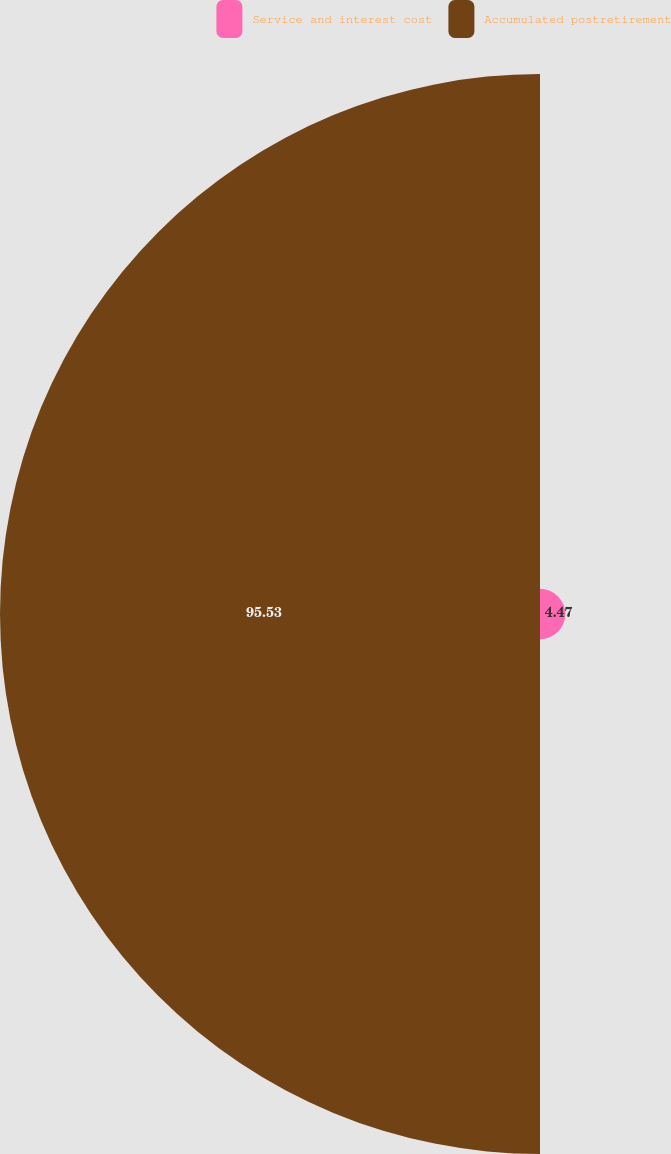Convert chart to OTSL. <chart><loc_0><loc_0><loc_500><loc_500><pie_chart><fcel>Service and interest cost<fcel>Accumulated postretirement<nl><fcel>4.47%<fcel>95.53%<nl></chart> 